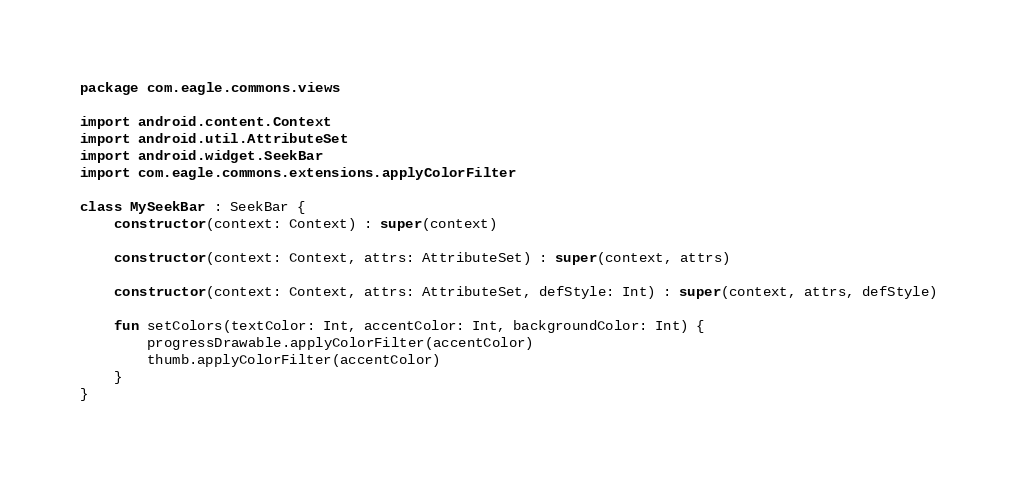<code> <loc_0><loc_0><loc_500><loc_500><_Kotlin_>package com.eagle.commons.views

import android.content.Context
import android.util.AttributeSet
import android.widget.SeekBar
import com.eagle.commons.extensions.applyColorFilter

class MySeekBar : SeekBar {
    constructor(context: Context) : super(context)

    constructor(context: Context, attrs: AttributeSet) : super(context, attrs)

    constructor(context: Context, attrs: AttributeSet, defStyle: Int) : super(context, attrs, defStyle)

    fun setColors(textColor: Int, accentColor: Int, backgroundColor: Int) {
        progressDrawable.applyColorFilter(accentColor)
        thumb.applyColorFilter(accentColor)
    }
}
</code> 